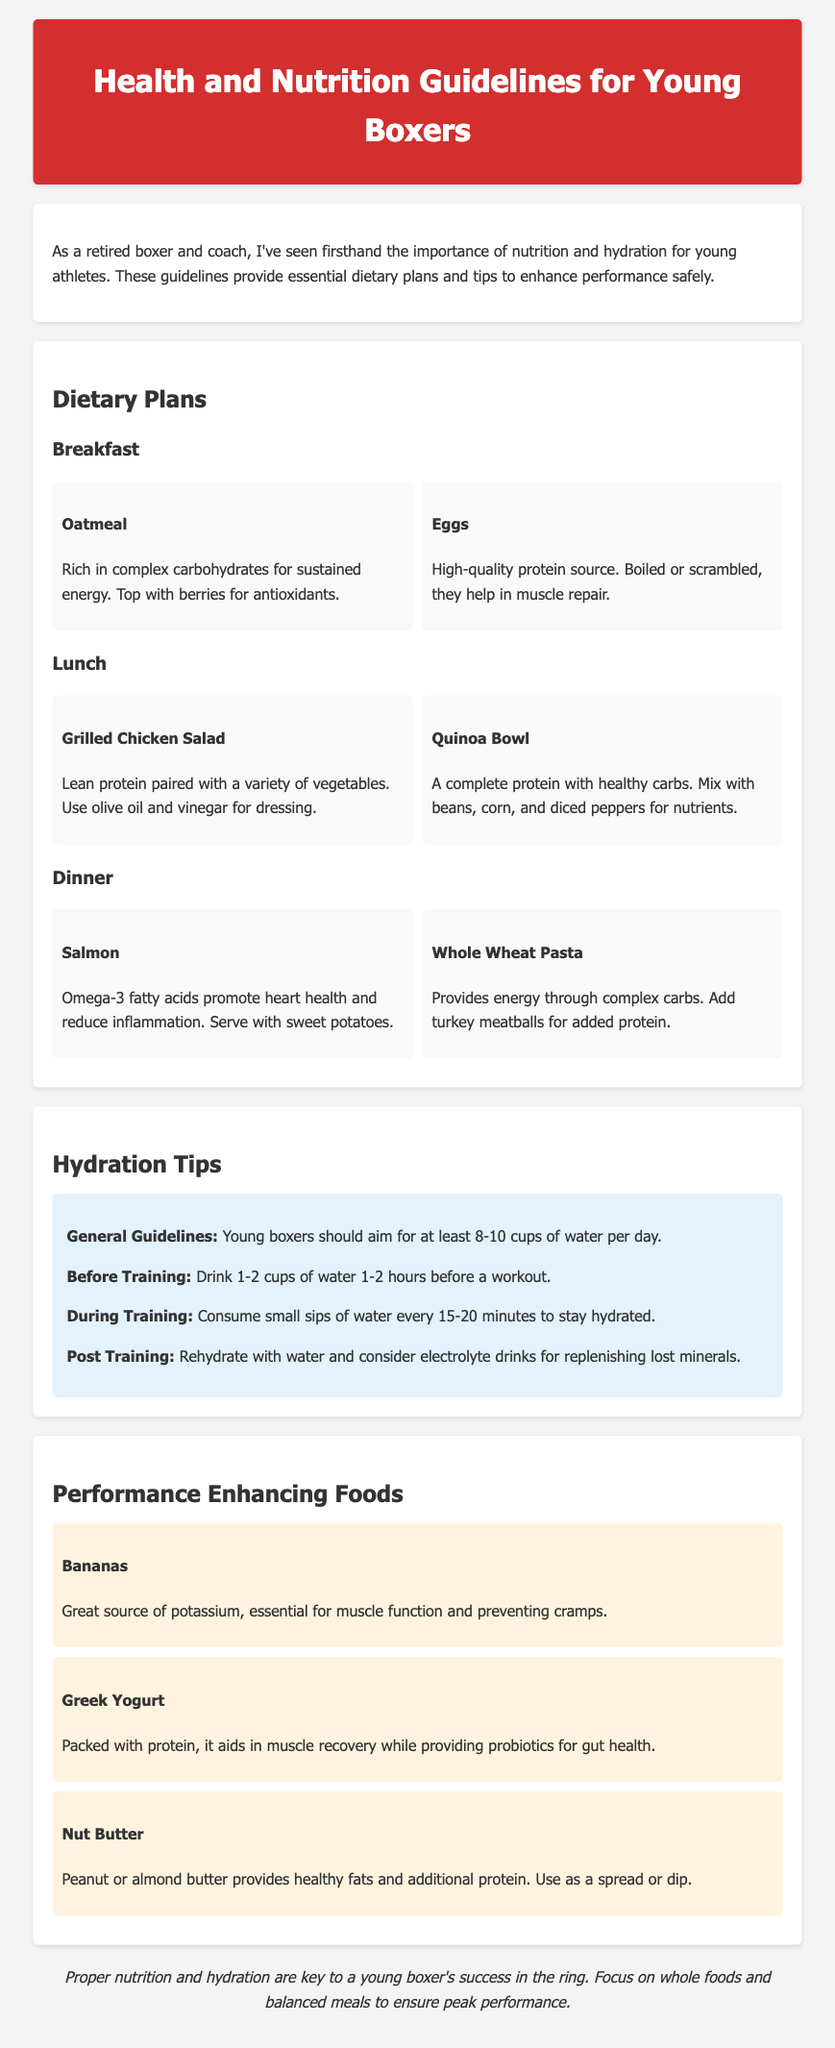what are the recommended daily water cups for young boxers? The document states that young boxers should aim for at least 8-10 cups of water per day.
Answer: 8-10 cups what is a high-quality protein source mentioned for breakfast? The note lists eggs as a high-quality protein source for breakfast.
Answer: Eggs which omega-3 rich food is suggested for dinner? Salmon is recommended for dinner as it contains omega-3 fatty acids.
Answer: Salmon what type of carbohydrates does oatmeal provide? Oatmeal is rich in complex carbohydrates for sustained energy.
Answer: Complex carbohydrates what is a performance-enhancing food that helps prevent cramps? Bananas are highlighted as a great source of potassium, essential for preventing cramps.
Answer: Bananas how should young boxers hydrate during training? The guideline suggests consuming small sips of water every 15-20 minutes during training.
Answer: Small sips every 15-20 minutes what topping is recommended for oatmeal? Berries are recommended as a topping for oatmeal to provide antioxidants.
Answer: Berries what is the purpose of consuming Greek yogurt according to the document? Greek yogurt aids in muscle recovery while providing probiotics for gut health.
Answer: Muscle recovery what meal includes grilled chicken and vegetables? The grilled chicken salad is the meal that includes lean protein paired with vegetables.
Answer: Grilled Chicken Salad 